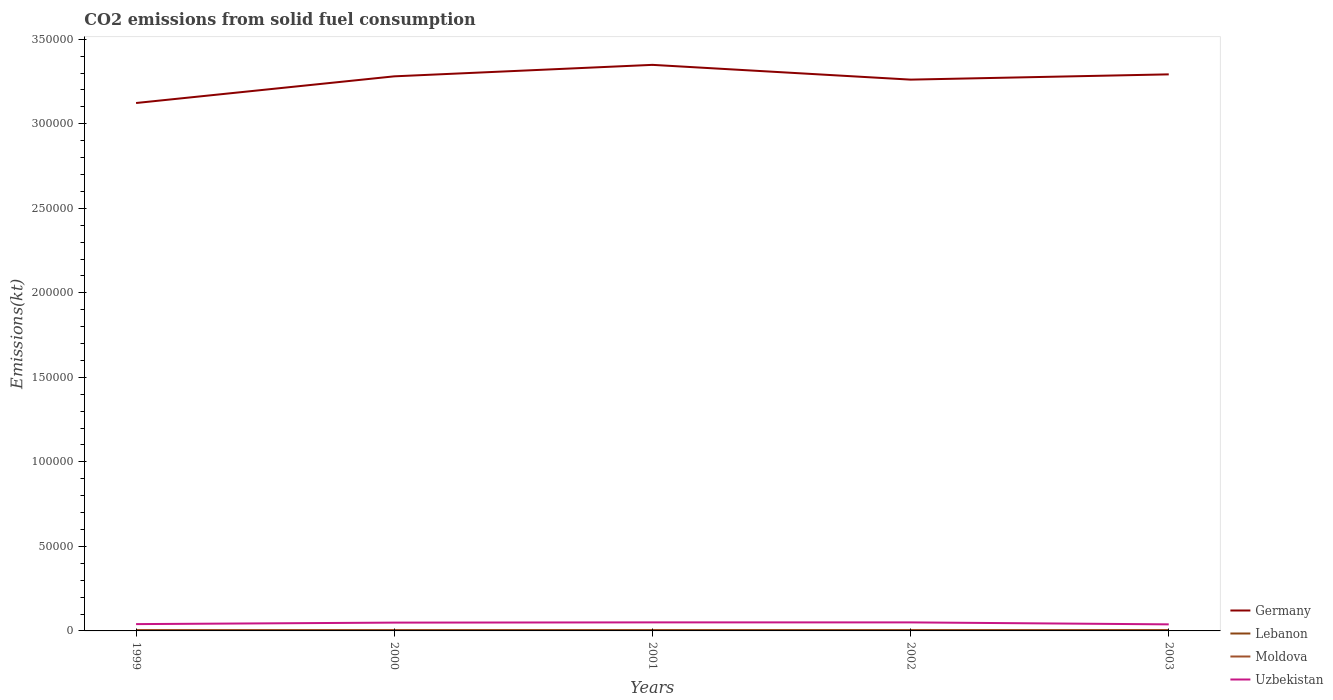How many different coloured lines are there?
Provide a succinct answer. 4. Across all years, what is the maximum amount of CO2 emitted in Uzbekistan?
Provide a succinct answer. 3879.69. In which year was the amount of CO2 emitted in Germany maximum?
Your answer should be very brief. 1999. What is the total amount of CO2 emitted in Moldova in the graph?
Offer a very short reply. 168.68. What is the difference between the highest and the second highest amount of CO2 emitted in Moldova?
Keep it short and to the point. 187.02. What is the difference between the highest and the lowest amount of CO2 emitted in Uzbekistan?
Provide a succinct answer. 3. Is the amount of CO2 emitted in Uzbekistan strictly greater than the amount of CO2 emitted in Lebanon over the years?
Make the answer very short. No. How many years are there in the graph?
Your response must be concise. 5. Does the graph contain grids?
Your response must be concise. No. Where does the legend appear in the graph?
Offer a very short reply. Bottom right. How many legend labels are there?
Offer a very short reply. 4. What is the title of the graph?
Offer a very short reply. CO2 emissions from solid fuel consumption. What is the label or title of the Y-axis?
Offer a terse response. Emissions(kt). What is the Emissions(kt) in Germany in 1999?
Your answer should be very brief. 3.12e+05. What is the Emissions(kt) of Lebanon in 1999?
Offer a very short reply. 535.38. What is the Emissions(kt) in Moldova in 1999?
Your answer should be very brief. 447.37. What is the Emissions(kt) in Uzbekistan in 1999?
Keep it short and to the point. 4030.03. What is the Emissions(kt) of Germany in 2000?
Your response must be concise. 3.28e+05. What is the Emissions(kt) of Lebanon in 2000?
Your answer should be compact. 535.38. What is the Emissions(kt) of Moldova in 2000?
Your answer should be compact. 366.7. What is the Emissions(kt) of Uzbekistan in 2000?
Ensure brevity in your answer.  4921.11. What is the Emissions(kt) of Germany in 2001?
Your answer should be very brief. 3.35e+05. What is the Emissions(kt) in Lebanon in 2001?
Your answer should be compact. 531.72. What is the Emissions(kt) of Moldova in 2001?
Keep it short and to the point. 260.36. What is the Emissions(kt) of Uzbekistan in 2001?
Your response must be concise. 5053.13. What is the Emissions(kt) in Germany in 2002?
Your answer should be compact. 3.26e+05. What is the Emissions(kt) of Lebanon in 2002?
Offer a very short reply. 531.72. What is the Emissions(kt) of Moldova in 2002?
Provide a short and direct response. 278.69. What is the Emissions(kt) of Uzbekistan in 2002?
Provide a succinct answer. 5045.79. What is the Emissions(kt) of Germany in 2003?
Offer a terse response. 3.29e+05. What is the Emissions(kt) in Lebanon in 2003?
Make the answer very short. 531.72. What is the Emissions(kt) of Moldova in 2003?
Offer a terse response. 337.36. What is the Emissions(kt) in Uzbekistan in 2003?
Keep it short and to the point. 3879.69. Across all years, what is the maximum Emissions(kt) of Germany?
Provide a succinct answer. 3.35e+05. Across all years, what is the maximum Emissions(kt) of Lebanon?
Ensure brevity in your answer.  535.38. Across all years, what is the maximum Emissions(kt) of Moldova?
Your answer should be very brief. 447.37. Across all years, what is the maximum Emissions(kt) in Uzbekistan?
Provide a short and direct response. 5053.13. Across all years, what is the minimum Emissions(kt) in Germany?
Keep it short and to the point. 3.12e+05. Across all years, what is the minimum Emissions(kt) in Lebanon?
Ensure brevity in your answer.  531.72. Across all years, what is the minimum Emissions(kt) in Moldova?
Offer a terse response. 260.36. Across all years, what is the minimum Emissions(kt) in Uzbekistan?
Keep it short and to the point. 3879.69. What is the total Emissions(kt) in Germany in the graph?
Ensure brevity in your answer.  1.63e+06. What is the total Emissions(kt) in Lebanon in the graph?
Your answer should be very brief. 2665.91. What is the total Emissions(kt) of Moldova in the graph?
Your answer should be compact. 1690.49. What is the total Emissions(kt) of Uzbekistan in the graph?
Your answer should be compact. 2.29e+04. What is the difference between the Emissions(kt) in Germany in 1999 and that in 2000?
Offer a terse response. -1.58e+04. What is the difference between the Emissions(kt) in Lebanon in 1999 and that in 2000?
Provide a succinct answer. 0. What is the difference between the Emissions(kt) of Moldova in 1999 and that in 2000?
Provide a short and direct response. 80.67. What is the difference between the Emissions(kt) of Uzbekistan in 1999 and that in 2000?
Give a very brief answer. -891.08. What is the difference between the Emissions(kt) in Germany in 1999 and that in 2001?
Your answer should be compact. -2.26e+04. What is the difference between the Emissions(kt) in Lebanon in 1999 and that in 2001?
Offer a very short reply. 3.67. What is the difference between the Emissions(kt) in Moldova in 1999 and that in 2001?
Offer a terse response. 187.02. What is the difference between the Emissions(kt) in Uzbekistan in 1999 and that in 2001?
Offer a terse response. -1023.09. What is the difference between the Emissions(kt) in Germany in 1999 and that in 2002?
Ensure brevity in your answer.  -1.38e+04. What is the difference between the Emissions(kt) of Lebanon in 1999 and that in 2002?
Make the answer very short. 3.67. What is the difference between the Emissions(kt) of Moldova in 1999 and that in 2002?
Provide a succinct answer. 168.68. What is the difference between the Emissions(kt) of Uzbekistan in 1999 and that in 2002?
Keep it short and to the point. -1015.76. What is the difference between the Emissions(kt) of Germany in 1999 and that in 2003?
Provide a short and direct response. -1.69e+04. What is the difference between the Emissions(kt) in Lebanon in 1999 and that in 2003?
Keep it short and to the point. 3.67. What is the difference between the Emissions(kt) of Moldova in 1999 and that in 2003?
Ensure brevity in your answer.  110.01. What is the difference between the Emissions(kt) of Uzbekistan in 1999 and that in 2003?
Give a very brief answer. 150.35. What is the difference between the Emissions(kt) in Germany in 2000 and that in 2001?
Give a very brief answer. -6791.28. What is the difference between the Emissions(kt) in Lebanon in 2000 and that in 2001?
Offer a very short reply. 3.67. What is the difference between the Emissions(kt) of Moldova in 2000 and that in 2001?
Ensure brevity in your answer.  106.34. What is the difference between the Emissions(kt) in Uzbekistan in 2000 and that in 2001?
Offer a terse response. -132.01. What is the difference between the Emissions(kt) of Germany in 2000 and that in 2002?
Provide a short and direct response. 1943.51. What is the difference between the Emissions(kt) of Lebanon in 2000 and that in 2002?
Make the answer very short. 3.67. What is the difference between the Emissions(kt) in Moldova in 2000 and that in 2002?
Ensure brevity in your answer.  88.01. What is the difference between the Emissions(kt) of Uzbekistan in 2000 and that in 2002?
Provide a short and direct response. -124.68. What is the difference between the Emissions(kt) of Germany in 2000 and that in 2003?
Your response must be concise. -1169.77. What is the difference between the Emissions(kt) of Lebanon in 2000 and that in 2003?
Give a very brief answer. 3.67. What is the difference between the Emissions(kt) in Moldova in 2000 and that in 2003?
Offer a terse response. 29.34. What is the difference between the Emissions(kt) in Uzbekistan in 2000 and that in 2003?
Your response must be concise. 1041.43. What is the difference between the Emissions(kt) in Germany in 2001 and that in 2002?
Offer a very short reply. 8734.79. What is the difference between the Emissions(kt) in Lebanon in 2001 and that in 2002?
Keep it short and to the point. 0. What is the difference between the Emissions(kt) in Moldova in 2001 and that in 2002?
Give a very brief answer. -18.34. What is the difference between the Emissions(kt) of Uzbekistan in 2001 and that in 2002?
Your answer should be very brief. 7.33. What is the difference between the Emissions(kt) of Germany in 2001 and that in 2003?
Offer a terse response. 5621.51. What is the difference between the Emissions(kt) in Lebanon in 2001 and that in 2003?
Your answer should be very brief. 0. What is the difference between the Emissions(kt) of Moldova in 2001 and that in 2003?
Provide a short and direct response. -77.01. What is the difference between the Emissions(kt) of Uzbekistan in 2001 and that in 2003?
Keep it short and to the point. 1173.44. What is the difference between the Emissions(kt) in Germany in 2002 and that in 2003?
Give a very brief answer. -3113.28. What is the difference between the Emissions(kt) of Lebanon in 2002 and that in 2003?
Ensure brevity in your answer.  0. What is the difference between the Emissions(kt) of Moldova in 2002 and that in 2003?
Your answer should be compact. -58.67. What is the difference between the Emissions(kt) in Uzbekistan in 2002 and that in 2003?
Your answer should be very brief. 1166.11. What is the difference between the Emissions(kt) of Germany in 1999 and the Emissions(kt) of Lebanon in 2000?
Provide a succinct answer. 3.12e+05. What is the difference between the Emissions(kt) of Germany in 1999 and the Emissions(kt) of Moldova in 2000?
Make the answer very short. 3.12e+05. What is the difference between the Emissions(kt) in Germany in 1999 and the Emissions(kt) in Uzbekistan in 2000?
Your response must be concise. 3.07e+05. What is the difference between the Emissions(kt) in Lebanon in 1999 and the Emissions(kt) in Moldova in 2000?
Give a very brief answer. 168.68. What is the difference between the Emissions(kt) of Lebanon in 1999 and the Emissions(kt) of Uzbekistan in 2000?
Keep it short and to the point. -4385.73. What is the difference between the Emissions(kt) of Moldova in 1999 and the Emissions(kt) of Uzbekistan in 2000?
Make the answer very short. -4473.74. What is the difference between the Emissions(kt) in Germany in 1999 and the Emissions(kt) in Lebanon in 2001?
Offer a very short reply. 3.12e+05. What is the difference between the Emissions(kt) of Germany in 1999 and the Emissions(kt) of Moldova in 2001?
Ensure brevity in your answer.  3.12e+05. What is the difference between the Emissions(kt) in Germany in 1999 and the Emissions(kt) in Uzbekistan in 2001?
Ensure brevity in your answer.  3.07e+05. What is the difference between the Emissions(kt) of Lebanon in 1999 and the Emissions(kt) of Moldova in 2001?
Offer a very short reply. 275.02. What is the difference between the Emissions(kt) in Lebanon in 1999 and the Emissions(kt) in Uzbekistan in 2001?
Provide a short and direct response. -4517.74. What is the difference between the Emissions(kt) of Moldova in 1999 and the Emissions(kt) of Uzbekistan in 2001?
Provide a succinct answer. -4605.75. What is the difference between the Emissions(kt) in Germany in 1999 and the Emissions(kt) in Lebanon in 2002?
Ensure brevity in your answer.  3.12e+05. What is the difference between the Emissions(kt) of Germany in 1999 and the Emissions(kt) of Moldova in 2002?
Keep it short and to the point. 3.12e+05. What is the difference between the Emissions(kt) in Germany in 1999 and the Emissions(kt) in Uzbekistan in 2002?
Give a very brief answer. 3.07e+05. What is the difference between the Emissions(kt) of Lebanon in 1999 and the Emissions(kt) of Moldova in 2002?
Ensure brevity in your answer.  256.69. What is the difference between the Emissions(kt) in Lebanon in 1999 and the Emissions(kt) in Uzbekistan in 2002?
Your response must be concise. -4510.41. What is the difference between the Emissions(kt) of Moldova in 1999 and the Emissions(kt) of Uzbekistan in 2002?
Ensure brevity in your answer.  -4598.42. What is the difference between the Emissions(kt) in Germany in 1999 and the Emissions(kt) in Lebanon in 2003?
Give a very brief answer. 3.12e+05. What is the difference between the Emissions(kt) in Germany in 1999 and the Emissions(kt) in Moldova in 2003?
Offer a terse response. 3.12e+05. What is the difference between the Emissions(kt) of Germany in 1999 and the Emissions(kt) of Uzbekistan in 2003?
Your answer should be compact. 3.08e+05. What is the difference between the Emissions(kt) of Lebanon in 1999 and the Emissions(kt) of Moldova in 2003?
Offer a terse response. 198.02. What is the difference between the Emissions(kt) of Lebanon in 1999 and the Emissions(kt) of Uzbekistan in 2003?
Provide a succinct answer. -3344.3. What is the difference between the Emissions(kt) of Moldova in 1999 and the Emissions(kt) of Uzbekistan in 2003?
Your answer should be very brief. -3432.31. What is the difference between the Emissions(kt) of Germany in 2000 and the Emissions(kt) of Lebanon in 2001?
Offer a terse response. 3.28e+05. What is the difference between the Emissions(kt) in Germany in 2000 and the Emissions(kt) in Moldova in 2001?
Your answer should be compact. 3.28e+05. What is the difference between the Emissions(kt) of Germany in 2000 and the Emissions(kt) of Uzbekistan in 2001?
Give a very brief answer. 3.23e+05. What is the difference between the Emissions(kt) of Lebanon in 2000 and the Emissions(kt) of Moldova in 2001?
Offer a terse response. 275.02. What is the difference between the Emissions(kt) in Lebanon in 2000 and the Emissions(kt) in Uzbekistan in 2001?
Your answer should be very brief. -4517.74. What is the difference between the Emissions(kt) in Moldova in 2000 and the Emissions(kt) in Uzbekistan in 2001?
Give a very brief answer. -4686.43. What is the difference between the Emissions(kt) in Germany in 2000 and the Emissions(kt) in Lebanon in 2002?
Keep it short and to the point. 3.28e+05. What is the difference between the Emissions(kt) of Germany in 2000 and the Emissions(kt) of Moldova in 2002?
Ensure brevity in your answer.  3.28e+05. What is the difference between the Emissions(kt) in Germany in 2000 and the Emissions(kt) in Uzbekistan in 2002?
Ensure brevity in your answer.  3.23e+05. What is the difference between the Emissions(kt) of Lebanon in 2000 and the Emissions(kt) of Moldova in 2002?
Offer a terse response. 256.69. What is the difference between the Emissions(kt) in Lebanon in 2000 and the Emissions(kt) in Uzbekistan in 2002?
Offer a very short reply. -4510.41. What is the difference between the Emissions(kt) of Moldova in 2000 and the Emissions(kt) of Uzbekistan in 2002?
Provide a short and direct response. -4679.09. What is the difference between the Emissions(kt) in Germany in 2000 and the Emissions(kt) in Lebanon in 2003?
Offer a terse response. 3.28e+05. What is the difference between the Emissions(kt) of Germany in 2000 and the Emissions(kt) of Moldova in 2003?
Your answer should be compact. 3.28e+05. What is the difference between the Emissions(kt) in Germany in 2000 and the Emissions(kt) in Uzbekistan in 2003?
Give a very brief answer. 3.24e+05. What is the difference between the Emissions(kt) of Lebanon in 2000 and the Emissions(kt) of Moldova in 2003?
Ensure brevity in your answer.  198.02. What is the difference between the Emissions(kt) in Lebanon in 2000 and the Emissions(kt) in Uzbekistan in 2003?
Offer a very short reply. -3344.3. What is the difference between the Emissions(kt) of Moldova in 2000 and the Emissions(kt) of Uzbekistan in 2003?
Your response must be concise. -3512.99. What is the difference between the Emissions(kt) of Germany in 2001 and the Emissions(kt) of Lebanon in 2002?
Your answer should be compact. 3.34e+05. What is the difference between the Emissions(kt) of Germany in 2001 and the Emissions(kt) of Moldova in 2002?
Your response must be concise. 3.35e+05. What is the difference between the Emissions(kt) of Germany in 2001 and the Emissions(kt) of Uzbekistan in 2002?
Give a very brief answer. 3.30e+05. What is the difference between the Emissions(kt) in Lebanon in 2001 and the Emissions(kt) in Moldova in 2002?
Provide a short and direct response. 253.02. What is the difference between the Emissions(kt) of Lebanon in 2001 and the Emissions(kt) of Uzbekistan in 2002?
Ensure brevity in your answer.  -4514.08. What is the difference between the Emissions(kt) of Moldova in 2001 and the Emissions(kt) of Uzbekistan in 2002?
Offer a terse response. -4785.44. What is the difference between the Emissions(kt) in Germany in 2001 and the Emissions(kt) in Lebanon in 2003?
Make the answer very short. 3.34e+05. What is the difference between the Emissions(kt) of Germany in 2001 and the Emissions(kt) of Moldova in 2003?
Provide a short and direct response. 3.35e+05. What is the difference between the Emissions(kt) of Germany in 2001 and the Emissions(kt) of Uzbekistan in 2003?
Provide a succinct answer. 3.31e+05. What is the difference between the Emissions(kt) of Lebanon in 2001 and the Emissions(kt) of Moldova in 2003?
Offer a terse response. 194.35. What is the difference between the Emissions(kt) of Lebanon in 2001 and the Emissions(kt) of Uzbekistan in 2003?
Provide a succinct answer. -3347.97. What is the difference between the Emissions(kt) of Moldova in 2001 and the Emissions(kt) of Uzbekistan in 2003?
Offer a very short reply. -3619.33. What is the difference between the Emissions(kt) in Germany in 2002 and the Emissions(kt) in Lebanon in 2003?
Keep it short and to the point. 3.26e+05. What is the difference between the Emissions(kt) in Germany in 2002 and the Emissions(kt) in Moldova in 2003?
Your response must be concise. 3.26e+05. What is the difference between the Emissions(kt) in Germany in 2002 and the Emissions(kt) in Uzbekistan in 2003?
Ensure brevity in your answer.  3.22e+05. What is the difference between the Emissions(kt) in Lebanon in 2002 and the Emissions(kt) in Moldova in 2003?
Provide a succinct answer. 194.35. What is the difference between the Emissions(kt) in Lebanon in 2002 and the Emissions(kt) in Uzbekistan in 2003?
Your answer should be very brief. -3347.97. What is the difference between the Emissions(kt) in Moldova in 2002 and the Emissions(kt) in Uzbekistan in 2003?
Your answer should be very brief. -3600.99. What is the average Emissions(kt) of Germany per year?
Keep it short and to the point. 3.26e+05. What is the average Emissions(kt) of Lebanon per year?
Ensure brevity in your answer.  533.18. What is the average Emissions(kt) in Moldova per year?
Offer a terse response. 338.1. What is the average Emissions(kt) of Uzbekistan per year?
Keep it short and to the point. 4585.95. In the year 1999, what is the difference between the Emissions(kt) of Germany and Emissions(kt) of Lebanon?
Give a very brief answer. 3.12e+05. In the year 1999, what is the difference between the Emissions(kt) in Germany and Emissions(kt) in Moldova?
Provide a succinct answer. 3.12e+05. In the year 1999, what is the difference between the Emissions(kt) in Germany and Emissions(kt) in Uzbekistan?
Your answer should be very brief. 3.08e+05. In the year 1999, what is the difference between the Emissions(kt) of Lebanon and Emissions(kt) of Moldova?
Your answer should be compact. 88.01. In the year 1999, what is the difference between the Emissions(kt) in Lebanon and Emissions(kt) in Uzbekistan?
Your answer should be compact. -3494.65. In the year 1999, what is the difference between the Emissions(kt) of Moldova and Emissions(kt) of Uzbekistan?
Your answer should be very brief. -3582.66. In the year 2000, what is the difference between the Emissions(kt) of Germany and Emissions(kt) of Lebanon?
Your answer should be compact. 3.28e+05. In the year 2000, what is the difference between the Emissions(kt) of Germany and Emissions(kt) of Moldova?
Keep it short and to the point. 3.28e+05. In the year 2000, what is the difference between the Emissions(kt) in Germany and Emissions(kt) in Uzbekistan?
Offer a very short reply. 3.23e+05. In the year 2000, what is the difference between the Emissions(kt) of Lebanon and Emissions(kt) of Moldova?
Provide a short and direct response. 168.68. In the year 2000, what is the difference between the Emissions(kt) in Lebanon and Emissions(kt) in Uzbekistan?
Offer a terse response. -4385.73. In the year 2000, what is the difference between the Emissions(kt) of Moldova and Emissions(kt) of Uzbekistan?
Provide a short and direct response. -4554.41. In the year 2001, what is the difference between the Emissions(kt) in Germany and Emissions(kt) in Lebanon?
Your answer should be compact. 3.34e+05. In the year 2001, what is the difference between the Emissions(kt) of Germany and Emissions(kt) of Moldova?
Provide a short and direct response. 3.35e+05. In the year 2001, what is the difference between the Emissions(kt) of Germany and Emissions(kt) of Uzbekistan?
Offer a very short reply. 3.30e+05. In the year 2001, what is the difference between the Emissions(kt) of Lebanon and Emissions(kt) of Moldova?
Offer a very short reply. 271.36. In the year 2001, what is the difference between the Emissions(kt) in Lebanon and Emissions(kt) in Uzbekistan?
Your answer should be very brief. -4521.41. In the year 2001, what is the difference between the Emissions(kt) of Moldova and Emissions(kt) of Uzbekistan?
Provide a succinct answer. -4792.77. In the year 2002, what is the difference between the Emissions(kt) in Germany and Emissions(kt) in Lebanon?
Provide a short and direct response. 3.26e+05. In the year 2002, what is the difference between the Emissions(kt) of Germany and Emissions(kt) of Moldova?
Make the answer very short. 3.26e+05. In the year 2002, what is the difference between the Emissions(kt) in Germany and Emissions(kt) in Uzbekistan?
Your response must be concise. 3.21e+05. In the year 2002, what is the difference between the Emissions(kt) in Lebanon and Emissions(kt) in Moldova?
Make the answer very short. 253.02. In the year 2002, what is the difference between the Emissions(kt) in Lebanon and Emissions(kt) in Uzbekistan?
Offer a terse response. -4514.08. In the year 2002, what is the difference between the Emissions(kt) in Moldova and Emissions(kt) in Uzbekistan?
Offer a terse response. -4767.1. In the year 2003, what is the difference between the Emissions(kt) of Germany and Emissions(kt) of Lebanon?
Your answer should be very brief. 3.29e+05. In the year 2003, what is the difference between the Emissions(kt) in Germany and Emissions(kt) in Moldova?
Your answer should be compact. 3.29e+05. In the year 2003, what is the difference between the Emissions(kt) in Germany and Emissions(kt) in Uzbekistan?
Provide a short and direct response. 3.25e+05. In the year 2003, what is the difference between the Emissions(kt) of Lebanon and Emissions(kt) of Moldova?
Give a very brief answer. 194.35. In the year 2003, what is the difference between the Emissions(kt) of Lebanon and Emissions(kt) of Uzbekistan?
Provide a succinct answer. -3347.97. In the year 2003, what is the difference between the Emissions(kt) of Moldova and Emissions(kt) of Uzbekistan?
Give a very brief answer. -3542.32. What is the ratio of the Emissions(kt) in Germany in 1999 to that in 2000?
Your answer should be compact. 0.95. What is the ratio of the Emissions(kt) of Moldova in 1999 to that in 2000?
Ensure brevity in your answer.  1.22. What is the ratio of the Emissions(kt) of Uzbekistan in 1999 to that in 2000?
Provide a short and direct response. 0.82. What is the ratio of the Emissions(kt) of Germany in 1999 to that in 2001?
Provide a succinct answer. 0.93. What is the ratio of the Emissions(kt) in Moldova in 1999 to that in 2001?
Keep it short and to the point. 1.72. What is the ratio of the Emissions(kt) of Uzbekistan in 1999 to that in 2001?
Ensure brevity in your answer.  0.8. What is the ratio of the Emissions(kt) in Germany in 1999 to that in 2002?
Make the answer very short. 0.96. What is the ratio of the Emissions(kt) of Moldova in 1999 to that in 2002?
Keep it short and to the point. 1.61. What is the ratio of the Emissions(kt) in Uzbekistan in 1999 to that in 2002?
Ensure brevity in your answer.  0.8. What is the ratio of the Emissions(kt) of Germany in 1999 to that in 2003?
Your response must be concise. 0.95. What is the ratio of the Emissions(kt) in Lebanon in 1999 to that in 2003?
Your response must be concise. 1.01. What is the ratio of the Emissions(kt) in Moldova in 1999 to that in 2003?
Your response must be concise. 1.33. What is the ratio of the Emissions(kt) of Uzbekistan in 1999 to that in 2003?
Give a very brief answer. 1.04. What is the ratio of the Emissions(kt) of Germany in 2000 to that in 2001?
Give a very brief answer. 0.98. What is the ratio of the Emissions(kt) in Moldova in 2000 to that in 2001?
Give a very brief answer. 1.41. What is the ratio of the Emissions(kt) of Uzbekistan in 2000 to that in 2001?
Make the answer very short. 0.97. What is the ratio of the Emissions(kt) of Moldova in 2000 to that in 2002?
Ensure brevity in your answer.  1.32. What is the ratio of the Emissions(kt) in Uzbekistan in 2000 to that in 2002?
Make the answer very short. 0.98. What is the ratio of the Emissions(kt) of Germany in 2000 to that in 2003?
Offer a very short reply. 1. What is the ratio of the Emissions(kt) in Moldova in 2000 to that in 2003?
Your response must be concise. 1.09. What is the ratio of the Emissions(kt) of Uzbekistan in 2000 to that in 2003?
Offer a very short reply. 1.27. What is the ratio of the Emissions(kt) of Germany in 2001 to that in 2002?
Your response must be concise. 1.03. What is the ratio of the Emissions(kt) in Moldova in 2001 to that in 2002?
Give a very brief answer. 0.93. What is the ratio of the Emissions(kt) of Uzbekistan in 2001 to that in 2002?
Your response must be concise. 1. What is the ratio of the Emissions(kt) in Germany in 2001 to that in 2003?
Provide a succinct answer. 1.02. What is the ratio of the Emissions(kt) in Moldova in 2001 to that in 2003?
Give a very brief answer. 0.77. What is the ratio of the Emissions(kt) in Uzbekistan in 2001 to that in 2003?
Your response must be concise. 1.3. What is the ratio of the Emissions(kt) in Lebanon in 2002 to that in 2003?
Make the answer very short. 1. What is the ratio of the Emissions(kt) in Moldova in 2002 to that in 2003?
Keep it short and to the point. 0.83. What is the ratio of the Emissions(kt) in Uzbekistan in 2002 to that in 2003?
Give a very brief answer. 1.3. What is the difference between the highest and the second highest Emissions(kt) of Germany?
Provide a short and direct response. 5621.51. What is the difference between the highest and the second highest Emissions(kt) of Lebanon?
Your answer should be very brief. 0. What is the difference between the highest and the second highest Emissions(kt) of Moldova?
Provide a short and direct response. 80.67. What is the difference between the highest and the second highest Emissions(kt) of Uzbekistan?
Make the answer very short. 7.33. What is the difference between the highest and the lowest Emissions(kt) in Germany?
Your answer should be very brief. 2.26e+04. What is the difference between the highest and the lowest Emissions(kt) of Lebanon?
Make the answer very short. 3.67. What is the difference between the highest and the lowest Emissions(kt) in Moldova?
Keep it short and to the point. 187.02. What is the difference between the highest and the lowest Emissions(kt) in Uzbekistan?
Provide a short and direct response. 1173.44. 